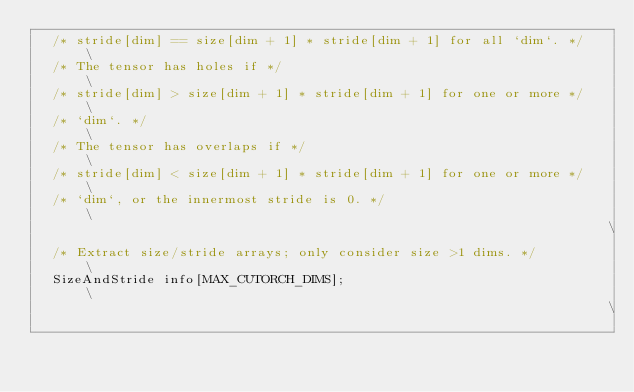Convert code to text. <code><loc_0><loc_0><loc_500><loc_500><_Cuda_>  /* stride[dim] == size[dim + 1] * stride[dim + 1] for all `dim`. */   \
  /* The tensor has holes if */                                         \
  /* stride[dim] > size[dim + 1] * stride[dim + 1] for one or more */   \
  /* `dim`. */                                                          \
  /* The tensor has overlaps if */                                      \
  /* stride[dim] < size[dim + 1] * stride[dim + 1] for one or more */   \
  /* `dim`, or the innermost stride is 0. */                            \
                                                                        \
  /* Extract size/stride arrays; only consider size >1 dims. */         \
  SizeAndStride info[MAX_CUTORCH_DIMS];                                 \
                                                                        \</code> 